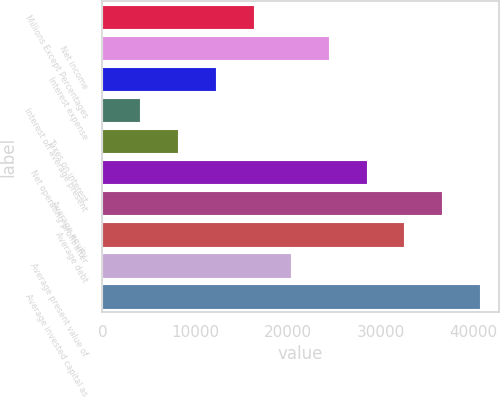<chart> <loc_0><loc_0><loc_500><loc_500><bar_chart><fcel>Millions Except Percentages<fcel>Net income<fcel>Interest expense<fcel>Interest on average present<fcel>Taxes on interest<fcel>Net operating profit after<fcel>Average equity<fcel>Average debt<fcel>Average present value of<fcel>Average invested capital as<nl><fcel>16279.8<fcel>24405.8<fcel>12216.7<fcel>4090.64<fcel>8153.68<fcel>28468.9<fcel>36595<fcel>32531.9<fcel>20342.8<fcel>40658<nl></chart> 